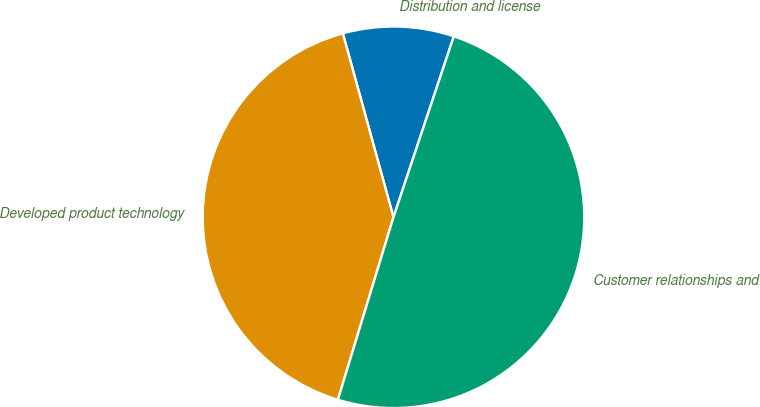Convert chart. <chart><loc_0><loc_0><loc_500><loc_500><pie_chart><fcel>Distribution and license<fcel>Developed product technology<fcel>Customer relationships and<nl><fcel>9.4%<fcel>41.02%<fcel>49.58%<nl></chart> 